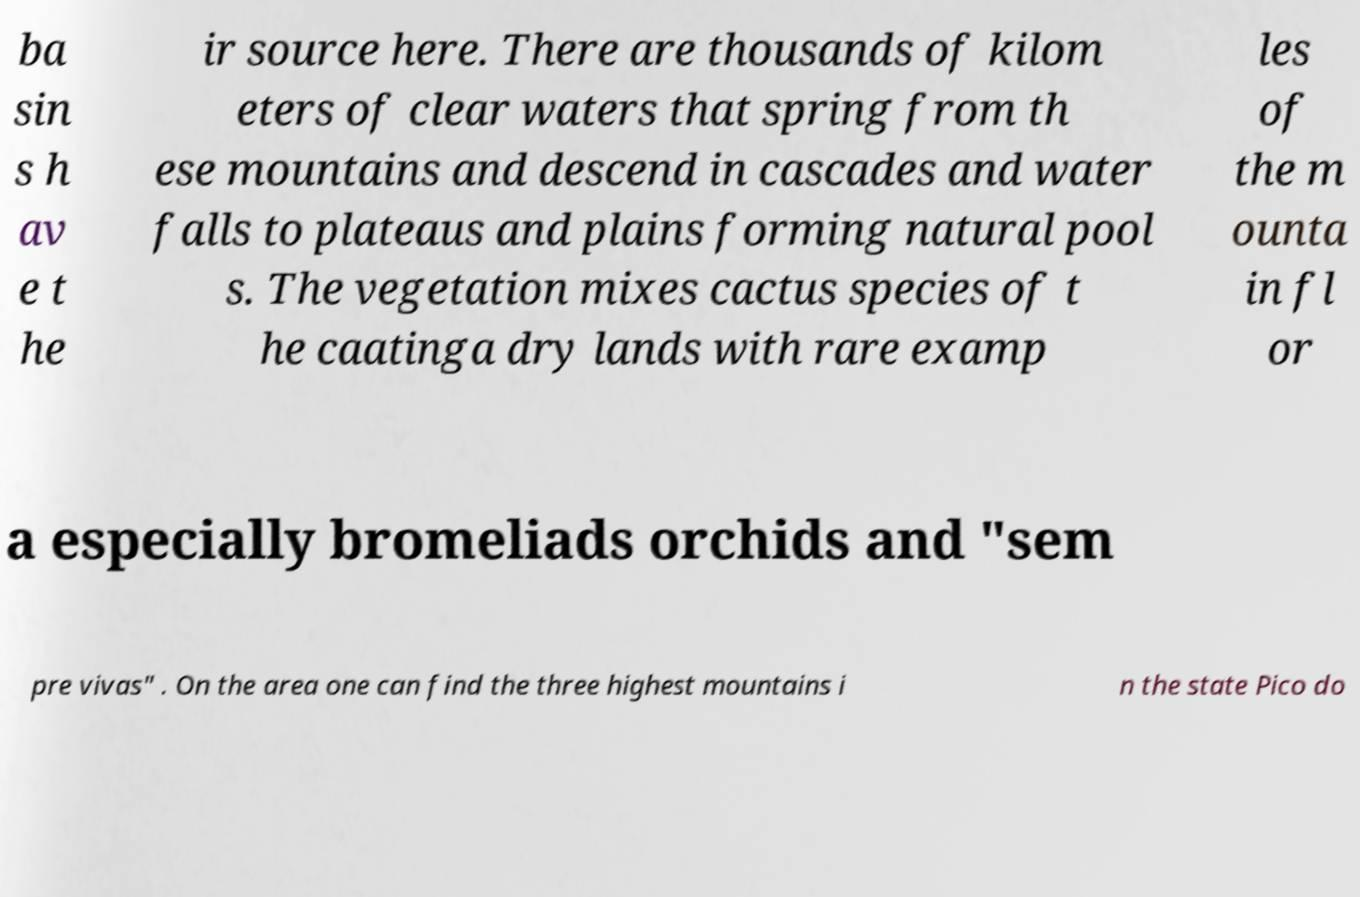Can you accurately transcribe the text from the provided image for me? ba sin s h av e t he ir source here. There are thousands of kilom eters of clear waters that spring from th ese mountains and descend in cascades and water falls to plateaus and plains forming natural pool s. The vegetation mixes cactus species of t he caatinga dry lands with rare examp les of the m ounta in fl or a especially bromeliads orchids and "sem pre vivas" . On the area one can find the three highest mountains i n the state Pico do 